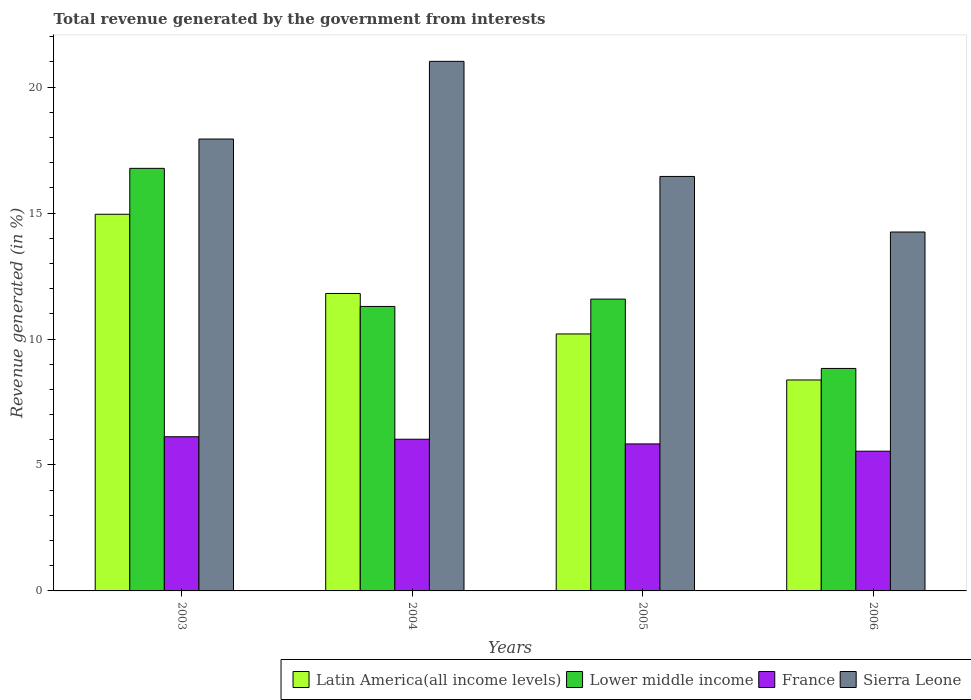What is the label of the 3rd group of bars from the left?
Make the answer very short. 2005. In how many cases, is the number of bars for a given year not equal to the number of legend labels?
Your answer should be very brief. 0. What is the total revenue generated in Latin America(all income levels) in 2004?
Your response must be concise. 11.81. Across all years, what is the maximum total revenue generated in Latin America(all income levels)?
Make the answer very short. 14.95. Across all years, what is the minimum total revenue generated in Lower middle income?
Give a very brief answer. 8.83. In which year was the total revenue generated in Lower middle income maximum?
Keep it short and to the point. 2003. What is the total total revenue generated in Sierra Leone in the graph?
Give a very brief answer. 69.66. What is the difference between the total revenue generated in France in 2004 and that in 2005?
Offer a very short reply. 0.19. What is the difference between the total revenue generated in France in 2005 and the total revenue generated in Latin America(all income levels) in 2006?
Offer a very short reply. -2.54. What is the average total revenue generated in Sierra Leone per year?
Offer a very short reply. 17.41. In the year 2003, what is the difference between the total revenue generated in France and total revenue generated in Sierra Leone?
Your response must be concise. -11.82. What is the ratio of the total revenue generated in Latin America(all income levels) in 2003 to that in 2004?
Make the answer very short. 1.27. Is the difference between the total revenue generated in France in 2004 and 2005 greater than the difference between the total revenue generated in Sierra Leone in 2004 and 2005?
Your answer should be very brief. No. What is the difference between the highest and the second highest total revenue generated in Sierra Leone?
Provide a short and direct response. 3.08. What is the difference between the highest and the lowest total revenue generated in Lower middle income?
Ensure brevity in your answer.  7.94. Is the sum of the total revenue generated in France in 2004 and 2006 greater than the maximum total revenue generated in Latin America(all income levels) across all years?
Your response must be concise. No. What does the 3rd bar from the right in 2005 represents?
Your answer should be very brief. Lower middle income. Are all the bars in the graph horizontal?
Make the answer very short. No. How many years are there in the graph?
Your answer should be very brief. 4. Does the graph contain any zero values?
Provide a succinct answer. No. Does the graph contain grids?
Your answer should be very brief. No. Where does the legend appear in the graph?
Your answer should be compact. Bottom right. How many legend labels are there?
Give a very brief answer. 4. What is the title of the graph?
Keep it short and to the point. Total revenue generated by the government from interests. Does "Peru" appear as one of the legend labels in the graph?
Keep it short and to the point. No. What is the label or title of the X-axis?
Offer a very short reply. Years. What is the label or title of the Y-axis?
Your answer should be compact. Revenue generated (in %). What is the Revenue generated (in %) of Latin America(all income levels) in 2003?
Your answer should be compact. 14.95. What is the Revenue generated (in %) of Lower middle income in 2003?
Give a very brief answer. 16.77. What is the Revenue generated (in %) of France in 2003?
Provide a succinct answer. 6.12. What is the Revenue generated (in %) in Sierra Leone in 2003?
Offer a very short reply. 17.94. What is the Revenue generated (in %) of Latin America(all income levels) in 2004?
Give a very brief answer. 11.81. What is the Revenue generated (in %) of Lower middle income in 2004?
Give a very brief answer. 11.29. What is the Revenue generated (in %) of France in 2004?
Provide a succinct answer. 6.02. What is the Revenue generated (in %) of Sierra Leone in 2004?
Your answer should be very brief. 21.02. What is the Revenue generated (in %) in Latin America(all income levels) in 2005?
Keep it short and to the point. 10.2. What is the Revenue generated (in %) of Lower middle income in 2005?
Provide a short and direct response. 11.58. What is the Revenue generated (in %) of France in 2005?
Offer a very short reply. 5.84. What is the Revenue generated (in %) in Sierra Leone in 2005?
Make the answer very short. 16.45. What is the Revenue generated (in %) of Latin America(all income levels) in 2006?
Your answer should be compact. 8.37. What is the Revenue generated (in %) of Lower middle income in 2006?
Ensure brevity in your answer.  8.83. What is the Revenue generated (in %) of France in 2006?
Give a very brief answer. 5.55. What is the Revenue generated (in %) of Sierra Leone in 2006?
Provide a short and direct response. 14.25. Across all years, what is the maximum Revenue generated (in %) of Latin America(all income levels)?
Provide a short and direct response. 14.95. Across all years, what is the maximum Revenue generated (in %) of Lower middle income?
Your answer should be very brief. 16.77. Across all years, what is the maximum Revenue generated (in %) in France?
Offer a terse response. 6.12. Across all years, what is the maximum Revenue generated (in %) of Sierra Leone?
Keep it short and to the point. 21.02. Across all years, what is the minimum Revenue generated (in %) in Latin America(all income levels)?
Provide a succinct answer. 8.37. Across all years, what is the minimum Revenue generated (in %) of Lower middle income?
Provide a succinct answer. 8.83. Across all years, what is the minimum Revenue generated (in %) in France?
Offer a very short reply. 5.55. Across all years, what is the minimum Revenue generated (in %) of Sierra Leone?
Your answer should be very brief. 14.25. What is the total Revenue generated (in %) of Latin America(all income levels) in the graph?
Make the answer very short. 45.33. What is the total Revenue generated (in %) of Lower middle income in the graph?
Make the answer very short. 48.48. What is the total Revenue generated (in %) of France in the graph?
Your answer should be compact. 23.52. What is the total Revenue generated (in %) of Sierra Leone in the graph?
Provide a short and direct response. 69.66. What is the difference between the Revenue generated (in %) of Latin America(all income levels) in 2003 and that in 2004?
Provide a short and direct response. 3.14. What is the difference between the Revenue generated (in %) of Lower middle income in 2003 and that in 2004?
Ensure brevity in your answer.  5.48. What is the difference between the Revenue generated (in %) of France in 2003 and that in 2004?
Your answer should be very brief. 0.1. What is the difference between the Revenue generated (in %) in Sierra Leone in 2003 and that in 2004?
Your answer should be compact. -3.08. What is the difference between the Revenue generated (in %) of Latin America(all income levels) in 2003 and that in 2005?
Your answer should be compact. 4.75. What is the difference between the Revenue generated (in %) in Lower middle income in 2003 and that in 2005?
Keep it short and to the point. 5.19. What is the difference between the Revenue generated (in %) of France in 2003 and that in 2005?
Your answer should be compact. 0.28. What is the difference between the Revenue generated (in %) of Sierra Leone in 2003 and that in 2005?
Ensure brevity in your answer.  1.49. What is the difference between the Revenue generated (in %) of Latin America(all income levels) in 2003 and that in 2006?
Your answer should be very brief. 6.58. What is the difference between the Revenue generated (in %) of Lower middle income in 2003 and that in 2006?
Give a very brief answer. 7.94. What is the difference between the Revenue generated (in %) in France in 2003 and that in 2006?
Provide a short and direct response. 0.57. What is the difference between the Revenue generated (in %) of Sierra Leone in 2003 and that in 2006?
Provide a succinct answer. 3.69. What is the difference between the Revenue generated (in %) in Latin America(all income levels) in 2004 and that in 2005?
Ensure brevity in your answer.  1.61. What is the difference between the Revenue generated (in %) of Lower middle income in 2004 and that in 2005?
Offer a very short reply. -0.29. What is the difference between the Revenue generated (in %) in France in 2004 and that in 2005?
Your response must be concise. 0.19. What is the difference between the Revenue generated (in %) of Sierra Leone in 2004 and that in 2005?
Your response must be concise. 4.57. What is the difference between the Revenue generated (in %) of Latin America(all income levels) in 2004 and that in 2006?
Offer a very short reply. 3.43. What is the difference between the Revenue generated (in %) of Lower middle income in 2004 and that in 2006?
Keep it short and to the point. 2.46. What is the difference between the Revenue generated (in %) in France in 2004 and that in 2006?
Ensure brevity in your answer.  0.48. What is the difference between the Revenue generated (in %) in Sierra Leone in 2004 and that in 2006?
Offer a terse response. 6.77. What is the difference between the Revenue generated (in %) of Latin America(all income levels) in 2005 and that in 2006?
Your answer should be compact. 1.83. What is the difference between the Revenue generated (in %) in Lower middle income in 2005 and that in 2006?
Offer a very short reply. 2.75. What is the difference between the Revenue generated (in %) of France in 2005 and that in 2006?
Offer a terse response. 0.29. What is the difference between the Revenue generated (in %) of Sierra Leone in 2005 and that in 2006?
Give a very brief answer. 2.21. What is the difference between the Revenue generated (in %) of Latin America(all income levels) in 2003 and the Revenue generated (in %) of Lower middle income in 2004?
Provide a succinct answer. 3.66. What is the difference between the Revenue generated (in %) in Latin America(all income levels) in 2003 and the Revenue generated (in %) in France in 2004?
Provide a succinct answer. 8.93. What is the difference between the Revenue generated (in %) of Latin America(all income levels) in 2003 and the Revenue generated (in %) of Sierra Leone in 2004?
Your answer should be very brief. -6.07. What is the difference between the Revenue generated (in %) of Lower middle income in 2003 and the Revenue generated (in %) of France in 2004?
Offer a very short reply. 10.75. What is the difference between the Revenue generated (in %) in Lower middle income in 2003 and the Revenue generated (in %) in Sierra Leone in 2004?
Make the answer very short. -4.25. What is the difference between the Revenue generated (in %) in France in 2003 and the Revenue generated (in %) in Sierra Leone in 2004?
Offer a terse response. -14.9. What is the difference between the Revenue generated (in %) in Latin America(all income levels) in 2003 and the Revenue generated (in %) in Lower middle income in 2005?
Provide a short and direct response. 3.37. What is the difference between the Revenue generated (in %) in Latin America(all income levels) in 2003 and the Revenue generated (in %) in France in 2005?
Your response must be concise. 9.12. What is the difference between the Revenue generated (in %) in Latin America(all income levels) in 2003 and the Revenue generated (in %) in Sierra Leone in 2005?
Keep it short and to the point. -1.5. What is the difference between the Revenue generated (in %) in Lower middle income in 2003 and the Revenue generated (in %) in France in 2005?
Your response must be concise. 10.94. What is the difference between the Revenue generated (in %) in Lower middle income in 2003 and the Revenue generated (in %) in Sierra Leone in 2005?
Your answer should be very brief. 0.32. What is the difference between the Revenue generated (in %) in France in 2003 and the Revenue generated (in %) in Sierra Leone in 2005?
Your answer should be compact. -10.33. What is the difference between the Revenue generated (in %) in Latin America(all income levels) in 2003 and the Revenue generated (in %) in Lower middle income in 2006?
Your answer should be compact. 6.12. What is the difference between the Revenue generated (in %) in Latin America(all income levels) in 2003 and the Revenue generated (in %) in France in 2006?
Ensure brevity in your answer.  9.41. What is the difference between the Revenue generated (in %) of Latin America(all income levels) in 2003 and the Revenue generated (in %) of Sierra Leone in 2006?
Ensure brevity in your answer.  0.71. What is the difference between the Revenue generated (in %) in Lower middle income in 2003 and the Revenue generated (in %) in France in 2006?
Ensure brevity in your answer.  11.23. What is the difference between the Revenue generated (in %) of Lower middle income in 2003 and the Revenue generated (in %) of Sierra Leone in 2006?
Your answer should be compact. 2.53. What is the difference between the Revenue generated (in %) in France in 2003 and the Revenue generated (in %) in Sierra Leone in 2006?
Ensure brevity in your answer.  -8.13. What is the difference between the Revenue generated (in %) in Latin America(all income levels) in 2004 and the Revenue generated (in %) in Lower middle income in 2005?
Provide a short and direct response. 0.22. What is the difference between the Revenue generated (in %) of Latin America(all income levels) in 2004 and the Revenue generated (in %) of France in 2005?
Offer a very short reply. 5.97. What is the difference between the Revenue generated (in %) in Latin America(all income levels) in 2004 and the Revenue generated (in %) in Sierra Leone in 2005?
Provide a short and direct response. -4.65. What is the difference between the Revenue generated (in %) of Lower middle income in 2004 and the Revenue generated (in %) of France in 2005?
Give a very brief answer. 5.46. What is the difference between the Revenue generated (in %) in Lower middle income in 2004 and the Revenue generated (in %) in Sierra Leone in 2005?
Give a very brief answer. -5.16. What is the difference between the Revenue generated (in %) in France in 2004 and the Revenue generated (in %) in Sierra Leone in 2005?
Make the answer very short. -10.43. What is the difference between the Revenue generated (in %) of Latin America(all income levels) in 2004 and the Revenue generated (in %) of Lower middle income in 2006?
Provide a succinct answer. 2.98. What is the difference between the Revenue generated (in %) in Latin America(all income levels) in 2004 and the Revenue generated (in %) in France in 2006?
Keep it short and to the point. 6.26. What is the difference between the Revenue generated (in %) in Latin America(all income levels) in 2004 and the Revenue generated (in %) in Sierra Leone in 2006?
Make the answer very short. -2.44. What is the difference between the Revenue generated (in %) in Lower middle income in 2004 and the Revenue generated (in %) in France in 2006?
Provide a succinct answer. 5.75. What is the difference between the Revenue generated (in %) in Lower middle income in 2004 and the Revenue generated (in %) in Sierra Leone in 2006?
Your response must be concise. -2.95. What is the difference between the Revenue generated (in %) of France in 2004 and the Revenue generated (in %) of Sierra Leone in 2006?
Provide a succinct answer. -8.22. What is the difference between the Revenue generated (in %) in Latin America(all income levels) in 2005 and the Revenue generated (in %) in Lower middle income in 2006?
Offer a terse response. 1.37. What is the difference between the Revenue generated (in %) of Latin America(all income levels) in 2005 and the Revenue generated (in %) of France in 2006?
Offer a terse response. 4.65. What is the difference between the Revenue generated (in %) of Latin America(all income levels) in 2005 and the Revenue generated (in %) of Sierra Leone in 2006?
Your answer should be very brief. -4.05. What is the difference between the Revenue generated (in %) in Lower middle income in 2005 and the Revenue generated (in %) in France in 2006?
Keep it short and to the point. 6.04. What is the difference between the Revenue generated (in %) of Lower middle income in 2005 and the Revenue generated (in %) of Sierra Leone in 2006?
Make the answer very short. -2.66. What is the difference between the Revenue generated (in %) of France in 2005 and the Revenue generated (in %) of Sierra Leone in 2006?
Make the answer very short. -8.41. What is the average Revenue generated (in %) of Latin America(all income levels) per year?
Keep it short and to the point. 11.33. What is the average Revenue generated (in %) in Lower middle income per year?
Offer a very short reply. 12.12. What is the average Revenue generated (in %) of France per year?
Give a very brief answer. 5.88. What is the average Revenue generated (in %) in Sierra Leone per year?
Provide a short and direct response. 17.41. In the year 2003, what is the difference between the Revenue generated (in %) of Latin America(all income levels) and Revenue generated (in %) of Lower middle income?
Make the answer very short. -1.82. In the year 2003, what is the difference between the Revenue generated (in %) of Latin America(all income levels) and Revenue generated (in %) of France?
Your response must be concise. 8.83. In the year 2003, what is the difference between the Revenue generated (in %) of Latin America(all income levels) and Revenue generated (in %) of Sierra Leone?
Provide a succinct answer. -2.99. In the year 2003, what is the difference between the Revenue generated (in %) of Lower middle income and Revenue generated (in %) of France?
Your response must be concise. 10.65. In the year 2003, what is the difference between the Revenue generated (in %) of Lower middle income and Revenue generated (in %) of Sierra Leone?
Make the answer very short. -1.16. In the year 2003, what is the difference between the Revenue generated (in %) in France and Revenue generated (in %) in Sierra Leone?
Offer a very short reply. -11.82. In the year 2004, what is the difference between the Revenue generated (in %) in Latin America(all income levels) and Revenue generated (in %) in Lower middle income?
Your response must be concise. 0.51. In the year 2004, what is the difference between the Revenue generated (in %) of Latin America(all income levels) and Revenue generated (in %) of France?
Provide a succinct answer. 5.79. In the year 2004, what is the difference between the Revenue generated (in %) in Latin America(all income levels) and Revenue generated (in %) in Sierra Leone?
Your response must be concise. -9.21. In the year 2004, what is the difference between the Revenue generated (in %) in Lower middle income and Revenue generated (in %) in France?
Your response must be concise. 5.27. In the year 2004, what is the difference between the Revenue generated (in %) in Lower middle income and Revenue generated (in %) in Sierra Leone?
Your response must be concise. -9.73. In the year 2004, what is the difference between the Revenue generated (in %) in France and Revenue generated (in %) in Sierra Leone?
Your answer should be compact. -15. In the year 2005, what is the difference between the Revenue generated (in %) in Latin America(all income levels) and Revenue generated (in %) in Lower middle income?
Give a very brief answer. -1.38. In the year 2005, what is the difference between the Revenue generated (in %) in Latin America(all income levels) and Revenue generated (in %) in France?
Provide a succinct answer. 4.37. In the year 2005, what is the difference between the Revenue generated (in %) of Latin America(all income levels) and Revenue generated (in %) of Sierra Leone?
Make the answer very short. -6.25. In the year 2005, what is the difference between the Revenue generated (in %) of Lower middle income and Revenue generated (in %) of France?
Ensure brevity in your answer.  5.75. In the year 2005, what is the difference between the Revenue generated (in %) of Lower middle income and Revenue generated (in %) of Sierra Leone?
Provide a short and direct response. -4.87. In the year 2005, what is the difference between the Revenue generated (in %) in France and Revenue generated (in %) in Sierra Leone?
Your answer should be compact. -10.62. In the year 2006, what is the difference between the Revenue generated (in %) of Latin America(all income levels) and Revenue generated (in %) of Lower middle income?
Your response must be concise. -0.46. In the year 2006, what is the difference between the Revenue generated (in %) of Latin America(all income levels) and Revenue generated (in %) of France?
Your answer should be compact. 2.83. In the year 2006, what is the difference between the Revenue generated (in %) of Latin America(all income levels) and Revenue generated (in %) of Sierra Leone?
Keep it short and to the point. -5.87. In the year 2006, what is the difference between the Revenue generated (in %) in Lower middle income and Revenue generated (in %) in France?
Ensure brevity in your answer.  3.28. In the year 2006, what is the difference between the Revenue generated (in %) in Lower middle income and Revenue generated (in %) in Sierra Leone?
Make the answer very short. -5.42. In the year 2006, what is the difference between the Revenue generated (in %) of France and Revenue generated (in %) of Sierra Leone?
Offer a very short reply. -8.7. What is the ratio of the Revenue generated (in %) of Latin America(all income levels) in 2003 to that in 2004?
Your response must be concise. 1.27. What is the ratio of the Revenue generated (in %) in Lower middle income in 2003 to that in 2004?
Provide a short and direct response. 1.49. What is the ratio of the Revenue generated (in %) in France in 2003 to that in 2004?
Your response must be concise. 1.02. What is the ratio of the Revenue generated (in %) of Sierra Leone in 2003 to that in 2004?
Provide a short and direct response. 0.85. What is the ratio of the Revenue generated (in %) of Latin America(all income levels) in 2003 to that in 2005?
Keep it short and to the point. 1.47. What is the ratio of the Revenue generated (in %) in Lower middle income in 2003 to that in 2005?
Offer a terse response. 1.45. What is the ratio of the Revenue generated (in %) in France in 2003 to that in 2005?
Your answer should be compact. 1.05. What is the ratio of the Revenue generated (in %) in Sierra Leone in 2003 to that in 2005?
Your answer should be compact. 1.09. What is the ratio of the Revenue generated (in %) in Latin America(all income levels) in 2003 to that in 2006?
Ensure brevity in your answer.  1.79. What is the ratio of the Revenue generated (in %) of Lower middle income in 2003 to that in 2006?
Give a very brief answer. 1.9. What is the ratio of the Revenue generated (in %) in France in 2003 to that in 2006?
Keep it short and to the point. 1.1. What is the ratio of the Revenue generated (in %) in Sierra Leone in 2003 to that in 2006?
Offer a very short reply. 1.26. What is the ratio of the Revenue generated (in %) in Latin America(all income levels) in 2004 to that in 2005?
Offer a terse response. 1.16. What is the ratio of the Revenue generated (in %) of Lower middle income in 2004 to that in 2005?
Offer a very short reply. 0.97. What is the ratio of the Revenue generated (in %) of France in 2004 to that in 2005?
Provide a succinct answer. 1.03. What is the ratio of the Revenue generated (in %) of Sierra Leone in 2004 to that in 2005?
Provide a short and direct response. 1.28. What is the ratio of the Revenue generated (in %) in Latin America(all income levels) in 2004 to that in 2006?
Offer a very short reply. 1.41. What is the ratio of the Revenue generated (in %) of Lower middle income in 2004 to that in 2006?
Offer a very short reply. 1.28. What is the ratio of the Revenue generated (in %) of France in 2004 to that in 2006?
Offer a terse response. 1.09. What is the ratio of the Revenue generated (in %) of Sierra Leone in 2004 to that in 2006?
Offer a terse response. 1.48. What is the ratio of the Revenue generated (in %) in Latin America(all income levels) in 2005 to that in 2006?
Keep it short and to the point. 1.22. What is the ratio of the Revenue generated (in %) in Lower middle income in 2005 to that in 2006?
Your response must be concise. 1.31. What is the ratio of the Revenue generated (in %) in France in 2005 to that in 2006?
Make the answer very short. 1.05. What is the ratio of the Revenue generated (in %) in Sierra Leone in 2005 to that in 2006?
Your answer should be very brief. 1.15. What is the difference between the highest and the second highest Revenue generated (in %) in Latin America(all income levels)?
Offer a very short reply. 3.14. What is the difference between the highest and the second highest Revenue generated (in %) in Lower middle income?
Offer a terse response. 5.19. What is the difference between the highest and the second highest Revenue generated (in %) in France?
Provide a succinct answer. 0.1. What is the difference between the highest and the second highest Revenue generated (in %) of Sierra Leone?
Make the answer very short. 3.08. What is the difference between the highest and the lowest Revenue generated (in %) of Latin America(all income levels)?
Keep it short and to the point. 6.58. What is the difference between the highest and the lowest Revenue generated (in %) in Lower middle income?
Your answer should be very brief. 7.94. What is the difference between the highest and the lowest Revenue generated (in %) of France?
Your answer should be very brief. 0.57. What is the difference between the highest and the lowest Revenue generated (in %) in Sierra Leone?
Keep it short and to the point. 6.77. 